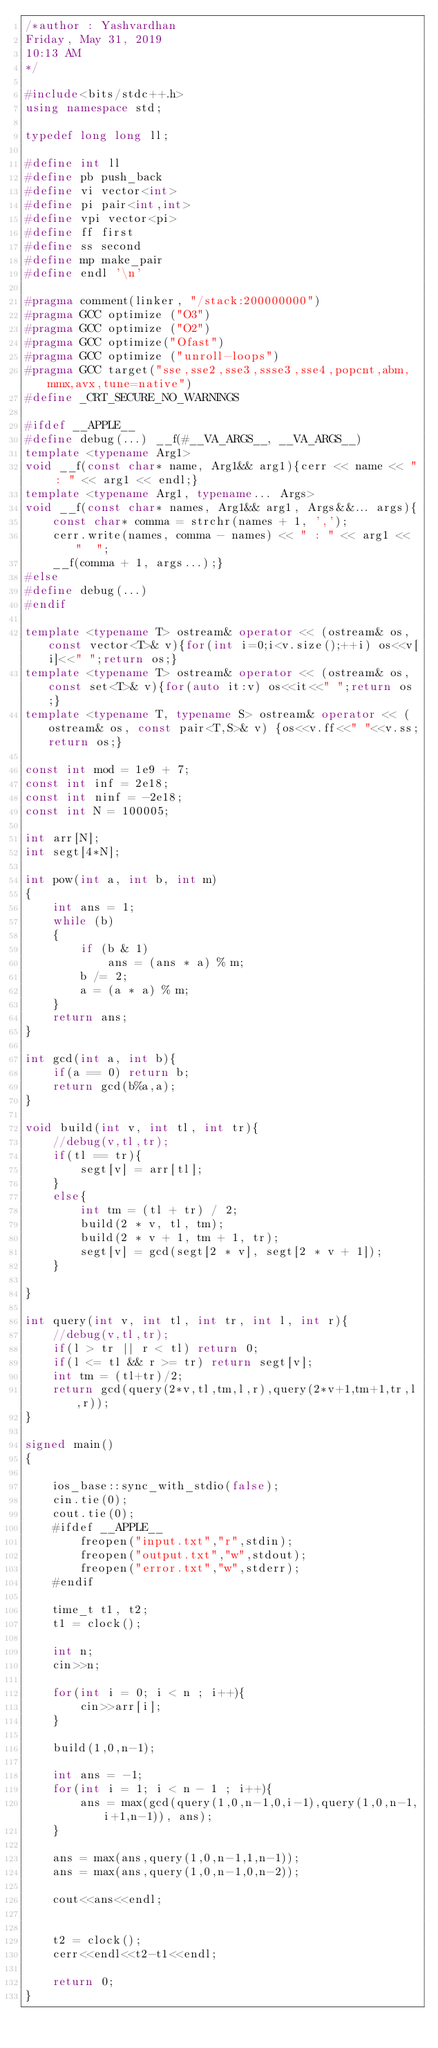Convert code to text. <code><loc_0><loc_0><loc_500><loc_500><_C++_>/*author : Yashvardhan
Friday, May 31, 2019
10:13 AM
*/

#include<bits/stdc++.h>
using namespace std;

typedef long long ll;

#define int ll
#define pb push_back
#define vi vector<int>
#define pi pair<int,int>
#define vpi vector<pi>
#define ff first
#define ss second
#define mp make_pair
#define endl '\n'

#pragma comment(linker, "/stack:200000000")
#pragma GCC optimize ("O3")
#pragma GCC optimize ("O2")
#pragma GCC optimize("Ofast")
#pragma GCC optimize ("unroll-loops")
#pragma GCC target("sse,sse2,sse3,ssse3,sse4,popcnt,abm,mmx,avx,tune=native")
#define _CRT_SECURE_NO_WARNINGS

#ifdef __APPLE__
#define debug(...) __f(#__VA_ARGS__, __VA_ARGS__)
template <typename Arg1>
void __f(const char* name, Arg1&& arg1){cerr << name << " : " << arg1 << endl;}
template <typename Arg1, typename... Args>
void __f(const char* names, Arg1&& arg1, Args&&... args){
	const char* comma = strchr(names + 1, ',');
	cerr.write(names, comma - names) << " : " << arg1 << "  ";
	__f(comma + 1, args...);}
#else
#define debug(...)
#endif

template <typename T> ostream& operator << (ostream& os,const vector<T>& v){for(int i=0;i<v.size();++i) os<<v[i]<<" ";return os;} 
template <typename T> ostream& operator << (ostream& os,const set<T>& v){for(auto it:v) os<<it<<" ";return os;} 
template <typename T, typename S> ostream& operator << (ostream& os, const pair<T,S>& v) {os<<v.ff<<" "<<v.ss;return os;}

const int mod = 1e9 + 7;
const int inf = 2e18;
const int ninf = -2e18;
const int N = 100005;

int arr[N];
int segt[4*N];

int pow(int a, int b, int m)
{
	int ans = 1;
	while (b)
	{
		if (b & 1)
			ans = (ans * a) % m;
		b /= 2;
		a = (a * a) % m;
	}
	return ans;
}

int gcd(int a, int b){
	if(a == 0) return b;
	return gcd(b%a,a);
}

void build(int v, int tl, int tr){
	//debug(v,tl,tr);
	if(tl == tr){
		segt[v] = arr[tl];
	}	
	else{
		int tm = (tl + tr) / 2;
		build(2 * v, tl, tm);
		build(2 * v + 1, tm + 1, tr);
		segt[v] = gcd(segt[2 * v], segt[2 * v + 1]);
	}
	
}

int query(int v, int tl, int tr, int l, int r){
	//debug(v,tl,tr);
	if(l > tr || r < tl) return 0;
	if(l <= tl && r >= tr) return segt[v];
	int tm = (tl+tr)/2;
	return gcd(query(2*v,tl,tm,l,r),query(2*v+1,tm+1,tr,l,r));
}

signed main()
{

	ios_base::sync_with_stdio(false);
	cin.tie(0);
	cout.tie(0);
	#ifdef __APPLE__
		freopen("input.txt","r",stdin);
		freopen("output.txt","w",stdout);
		freopen("error.txt","w",stderr);
	#endif

	time_t t1, t2;
	t1 = clock();
	
	int n;
	cin>>n;

	for(int i = 0; i < n ; i++){
		cin>>arr[i];
	}

	build(1,0,n-1);

	int ans = -1;
	for(int i = 1; i < n - 1 ; i++){
		ans = max(gcd(query(1,0,n-1,0,i-1),query(1,0,n-1,i+1,n-1)), ans);
	}

	ans = max(ans,query(1,0,n-1,1,n-1));
	ans = max(ans,query(1,0,n-1,0,n-2));

	cout<<ans<<endl;
	

	t2 = clock();
	cerr<<endl<<t2-t1<<endl;
	
	return 0;
}

</code> 